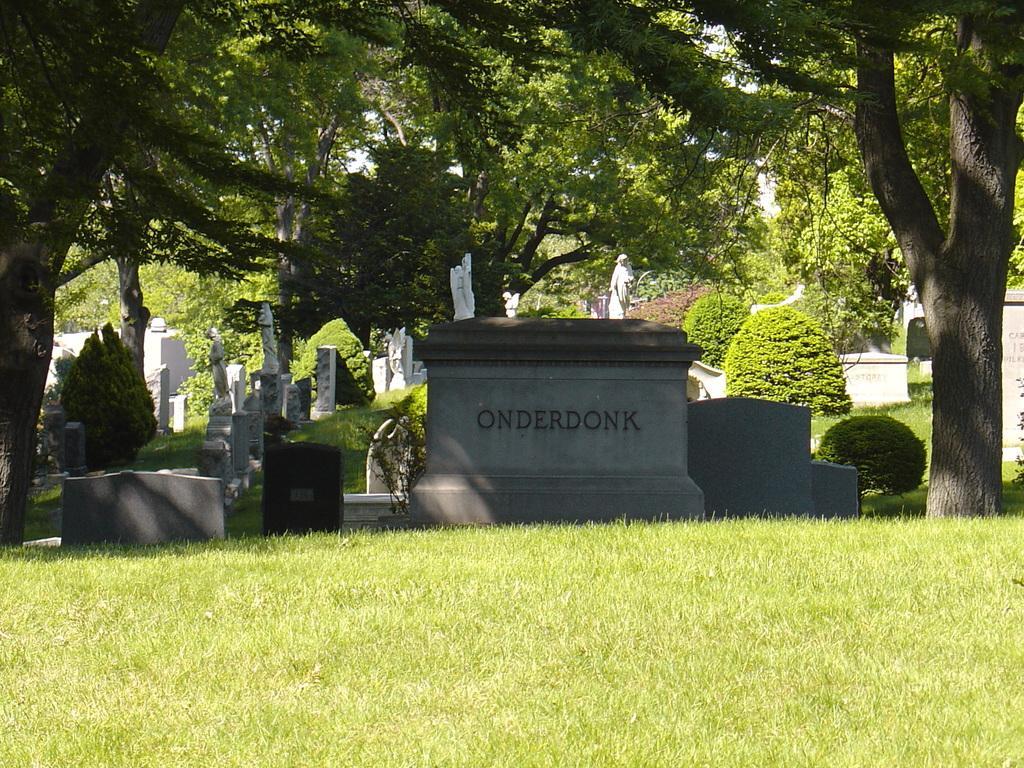In one or two sentences, can you explain what this image depicts? In the image we can see headstone and sculptures. We can even see grass, plants and trees. 